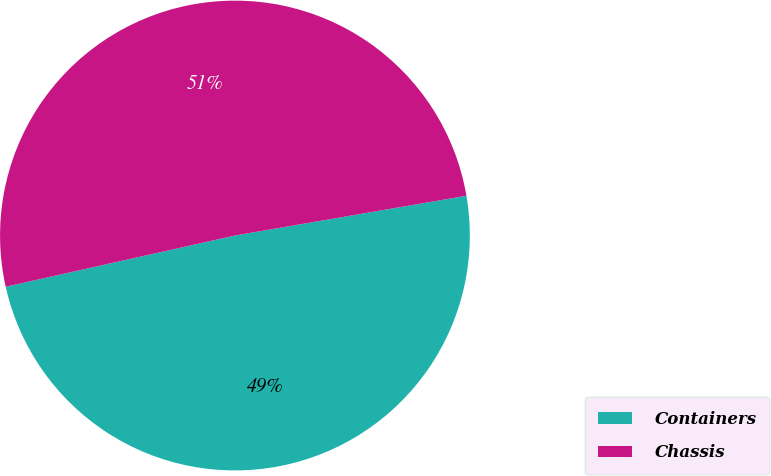Convert chart to OTSL. <chart><loc_0><loc_0><loc_500><loc_500><pie_chart><fcel>Containers<fcel>Chassis<nl><fcel>49.21%<fcel>50.79%<nl></chart> 